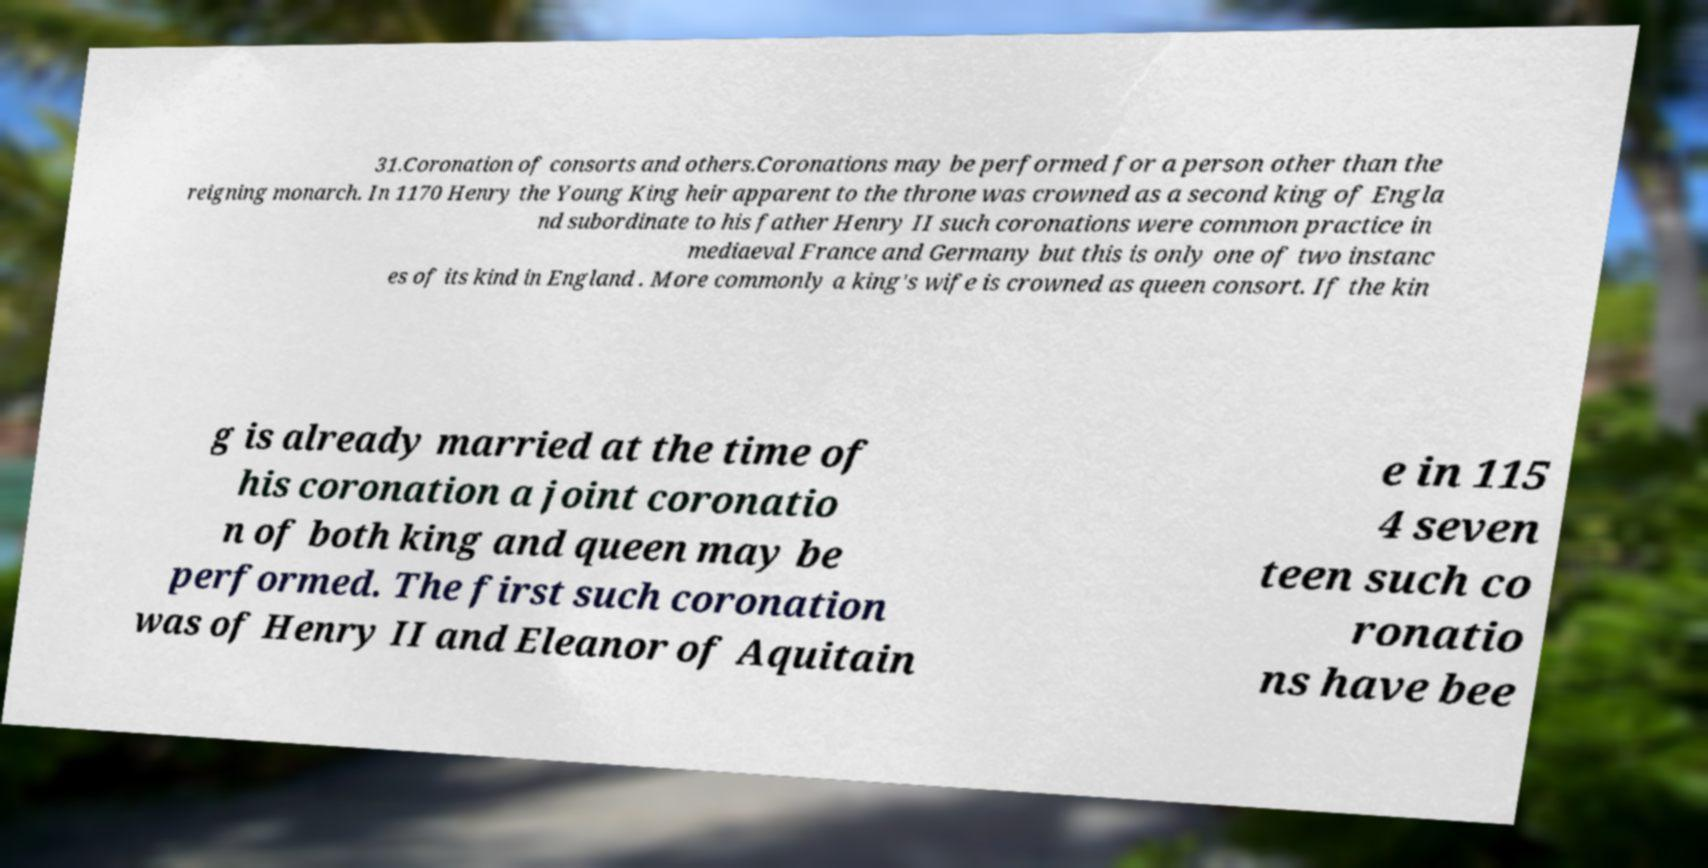Could you extract and type out the text from this image? 31.Coronation of consorts and others.Coronations may be performed for a person other than the reigning monarch. In 1170 Henry the Young King heir apparent to the throne was crowned as a second king of Engla nd subordinate to his father Henry II such coronations were common practice in mediaeval France and Germany but this is only one of two instanc es of its kind in England . More commonly a king's wife is crowned as queen consort. If the kin g is already married at the time of his coronation a joint coronatio n of both king and queen may be performed. The first such coronation was of Henry II and Eleanor of Aquitain e in 115 4 seven teen such co ronatio ns have bee 